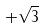Convert formula to latex. <formula><loc_0><loc_0><loc_500><loc_500>+ \sqrt { 3 }</formula> 